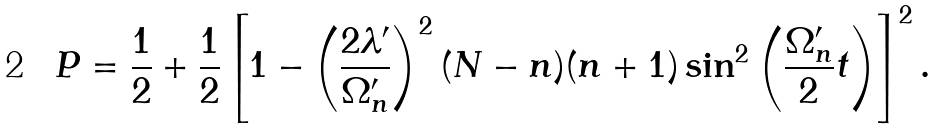<formula> <loc_0><loc_0><loc_500><loc_500>P = \frac { 1 } { 2 } + \frac { 1 } { 2 } \left [ 1 - \left ( \frac { 2 \lambda ^ { \prime } } { \Omega _ { n } ^ { \prime } } \right ) ^ { 2 } ( N - n ) ( n + 1 ) \sin ^ { 2 } \left ( \frac { \Omega _ { n } ^ { \prime } } { 2 } t \right ) \right ] ^ { 2 } .</formula> 